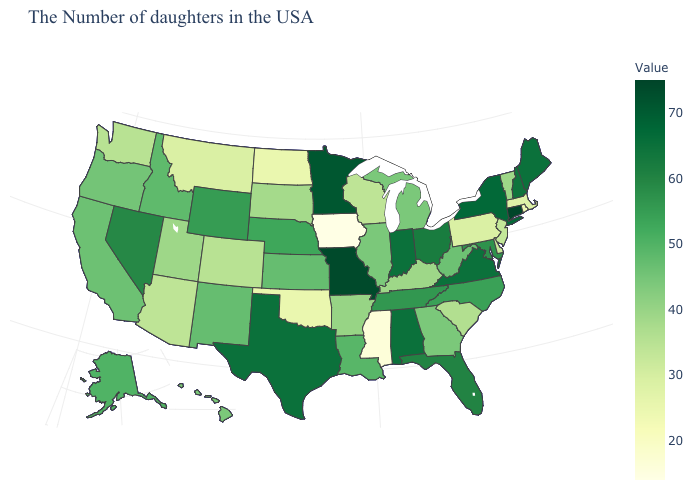Which states have the highest value in the USA?
Quick response, please. Connecticut. Does Pennsylvania have a lower value than Iowa?
Answer briefly. No. Which states have the lowest value in the USA?
Quick response, please. Iowa. Does Louisiana have a higher value than Tennessee?
Be succinct. No. 